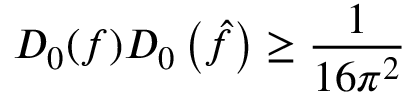Convert formula to latex. <formula><loc_0><loc_0><loc_500><loc_500>D _ { 0 } ( f ) D _ { 0 } \left ( { \hat { f } } \right ) \geq { \frac { 1 } { 1 6 \pi ^ { 2 } } }</formula> 